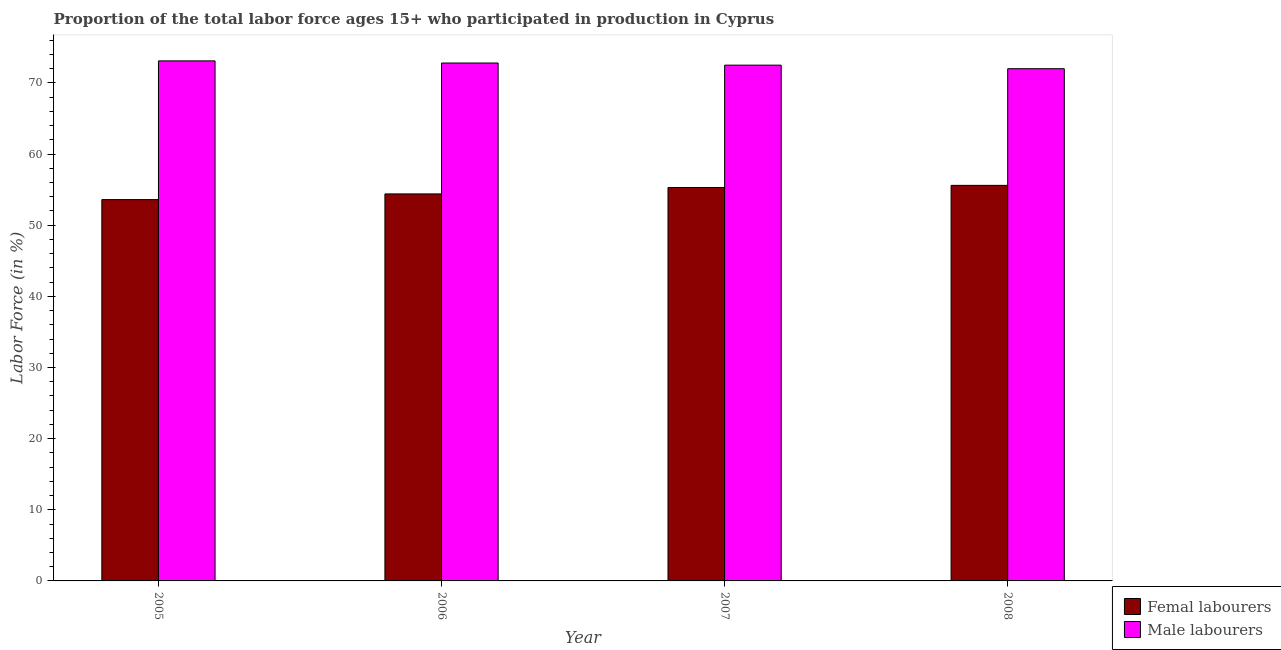Are the number of bars on each tick of the X-axis equal?
Make the answer very short. Yes. How many bars are there on the 2nd tick from the left?
Provide a short and direct response. 2. What is the label of the 2nd group of bars from the left?
Your answer should be compact. 2006. What is the percentage of female labor force in 2008?
Offer a terse response. 55.6. Across all years, what is the maximum percentage of female labor force?
Offer a terse response. 55.6. Across all years, what is the minimum percentage of male labour force?
Your answer should be compact. 72. In which year was the percentage of male labour force minimum?
Your answer should be very brief. 2008. What is the total percentage of male labour force in the graph?
Your response must be concise. 290.4. What is the difference between the percentage of male labour force in 2005 and that in 2006?
Your answer should be compact. 0.3. What is the difference between the percentage of female labor force in 2006 and the percentage of male labour force in 2007?
Make the answer very short. -0.9. What is the average percentage of female labor force per year?
Offer a very short reply. 54.72. In how many years, is the percentage of male labour force greater than 6 %?
Your answer should be compact. 4. What is the ratio of the percentage of female labor force in 2006 to that in 2008?
Provide a short and direct response. 0.98. What is the difference between the highest and the second highest percentage of male labour force?
Provide a succinct answer. 0.3. What is the difference between the highest and the lowest percentage of female labor force?
Offer a terse response. 2. In how many years, is the percentage of female labor force greater than the average percentage of female labor force taken over all years?
Ensure brevity in your answer.  2. What does the 1st bar from the left in 2005 represents?
Your answer should be very brief. Femal labourers. What does the 1st bar from the right in 2008 represents?
Provide a short and direct response. Male labourers. How many years are there in the graph?
Ensure brevity in your answer.  4. Are the values on the major ticks of Y-axis written in scientific E-notation?
Give a very brief answer. No. Does the graph contain grids?
Offer a very short reply. No. Where does the legend appear in the graph?
Offer a terse response. Bottom right. How are the legend labels stacked?
Your answer should be very brief. Vertical. What is the title of the graph?
Offer a terse response. Proportion of the total labor force ages 15+ who participated in production in Cyprus. Does "Chemicals" appear as one of the legend labels in the graph?
Provide a short and direct response. No. What is the Labor Force (in %) of Femal labourers in 2005?
Your answer should be compact. 53.6. What is the Labor Force (in %) of Male labourers in 2005?
Your answer should be very brief. 73.1. What is the Labor Force (in %) of Femal labourers in 2006?
Provide a succinct answer. 54.4. What is the Labor Force (in %) in Male labourers in 2006?
Your response must be concise. 72.8. What is the Labor Force (in %) in Femal labourers in 2007?
Provide a succinct answer. 55.3. What is the Labor Force (in %) in Male labourers in 2007?
Give a very brief answer. 72.5. What is the Labor Force (in %) of Femal labourers in 2008?
Offer a very short reply. 55.6. What is the Labor Force (in %) in Male labourers in 2008?
Provide a succinct answer. 72. Across all years, what is the maximum Labor Force (in %) of Femal labourers?
Provide a succinct answer. 55.6. Across all years, what is the maximum Labor Force (in %) of Male labourers?
Make the answer very short. 73.1. Across all years, what is the minimum Labor Force (in %) of Femal labourers?
Give a very brief answer. 53.6. What is the total Labor Force (in %) of Femal labourers in the graph?
Offer a very short reply. 218.9. What is the total Labor Force (in %) in Male labourers in the graph?
Ensure brevity in your answer.  290.4. What is the difference between the Labor Force (in %) in Male labourers in 2005 and that in 2006?
Offer a very short reply. 0.3. What is the difference between the Labor Force (in %) of Femal labourers in 2005 and that in 2008?
Your response must be concise. -2. What is the difference between the Labor Force (in %) of Male labourers in 2005 and that in 2008?
Ensure brevity in your answer.  1.1. What is the difference between the Labor Force (in %) in Male labourers in 2006 and that in 2007?
Give a very brief answer. 0.3. What is the difference between the Labor Force (in %) of Femal labourers in 2006 and that in 2008?
Ensure brevity in your answer.  -1.2. What is the difference between the Labor Force (in %) of Male labourers in 2006 and that in 2008?
Keep it short and to the point. 0.8. What is the difference between the Labor Force (in %) in Femal labourers in 2007 and that in 2008?
Keep it short and to the point. -0.3. What is the difference between the Labor Force (in %) of Male labourers in 2007 and that in 2008?
Your response must be concise. 0.5. What is the difference between the Labor Force (in %) in Femal labourers in 2005 and the Labor Force (in %) in Male labourers in 2006?
Offer a very short reply. -19.2. What is the difference between the Labor Force (in %) of Femal labourers in 2005 and the Labor Force (in %) of Male labourers in 2007?
Give a very brief answer. -18.9. What is the difference between the Labor Force (in %) in Femal labourers in 2005 and the Labor Force (in %) in Male labourers in 2008?
Ensure brevity in your answer.  -18.4. What is the difference between the Labor Force (in %) in Femal labourers in 2006 and the Labor Force (in %) in Male labourers in 2007?
Ensure brevity in your answer.  -18.1. What is the difference between the Labor Force (in %) in Femal labourers in 2006 and the Labor Force (in %) in Male labourers in 2008?
Keep it short and to the point. -17.6. What is the difference between the Labor Force (in %) of Femal labourers in 2007 and the Labor Force (in %) of Male labourers in 2008?
Your answer should be very brief. -16.7. What is the average Labor Force (in %) in Femal labourers per year?
Provide a short and direct response. 54.73. What is the average Labor Force (in %) in Male labourers per year?
Give a very brief answer. 72.6. In the year 2005, what is the difference between the Labor Force (in %) in Femal labourers and Labor Force (in %) in Male labourers?
Offer a very short reply. -19.5. In the year 2006, what is the difference between the Labor Force (in %) of Femal labourers and Labor Force (in %) of Male labourers?
Your answer should be compact. -18.4. In the year 2007, what is the difference between the Labor Force (in %) in Femal labourers and Labor Force (in %) in Male labourers?
Provide a short and direct response. -17.2. In the year 2008, what is the difference between the Labor Force (in %) in Femal labourers and Labor Force (in %) in Male labourers?
Your answer should be very brief. -16.4. What is the ratio of the Labor Force (in %) in Femal labourers in 2005 to that in 2006?
Provide a succinct answer. 0.99. What is the ratio of the Labor Force (in %) of Male labourers in 2005 to that in 2006?
Provide a succinct answer. 1. What is the ratio of the Labor Force (in %) of Femal labourers in 2005 to that in 2007?
Offer a terse response. 0.97. What is the ratio of the Labor Force (in %) in Male labourers in 2005 to that in 2007?
Give a very brief answer. 1.01. What is the ratio of the Labor Force (in %) in Femal labourers in 2005 to that in 2008?
Offer a very short reply. 0.96. What is the ratio of the Labor Force (in %) in Male labourers in 2005 to that in 2008?
Make the answer very short. 1.02. What is the ratio of the Labor Force (in %) of Femal labourers in 2006 to that in 2007?
Offer a terse response. 0.98. What is the ratio of the Labor Force (in %) of Male labourers in 2006 to that in 2007?
Your response must be concise. 1. What is the ratio of the Labor Force (in %) of Femal labourers in 2006 to that in 2008?
Ensure brevity in your answer.  0.98. What is the ratio of the Labor Force (in %) in Male labourers in 2006 to that in 2008?
Keep it short and to the point. 1.01. What is the ratio of the Labor Force (in %) of Femal labourers in 2007 to that in 2008?
Your answer should be very brief. 0.99. What is the ratio of the Labor Force (in %) in Male labourers in 2007 to that in 2008?
Provide a short and direct response. 1.01. What is the difference between the highest and the second highest Labor Force (in %) in Femal labourers?
Make the answer very short. 0.3. What is the difference between the highest and the second highest Labor Force (in %) in Male labourers?
Keep it short and to the point. 0.3. What is the difference between the highest and the lowest Labor Force (in %) of Male labourers?
Give a very brief answer. 1.1. 